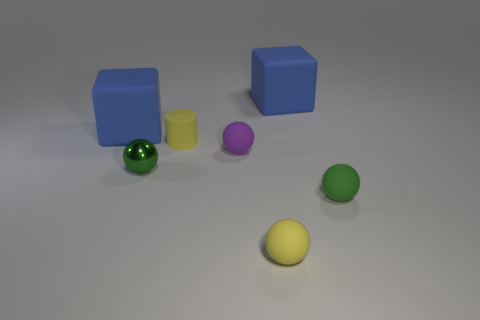There is a yellow matte ball; is its size the same as the blue rubber object right of the purple matte sphere?
Give a very brief answer. No. Is there a large yellow metal sphere?
Your answer should be compact. No. What is the material of the tiny yellow object that is the same shape as the green shiny object?
Provide a succinct answer. Rubber. There is a yellow thing that is in front of the green sphere left of the large blue block that is to the right of the small purple sphere; how big is it?
Your answer should be very brief. Small. Are there any large blue rubber cubes to the left of the yellow matte cylinder?
Your answer should be very brief. Yes. There is a purple ball that is the same material as the cylinder; what is its size?
Give a very brief answer. Small. What number of other tiny matte things are the same shape as the tiny green rubber object?
Your answer should be compact. 2. Are the yellow ball and the green ball that is to the left of the tiny cylinder made of the same material?
Provide a succinct answer. No. Are there more small rubber cylinders that are right of the green shiny ball than big green things?
Provide a succinct answer. Yes. There is a small rubber object that is the same color as the shiny thing; what is its shape?
Offer a terse response. Sphere. 